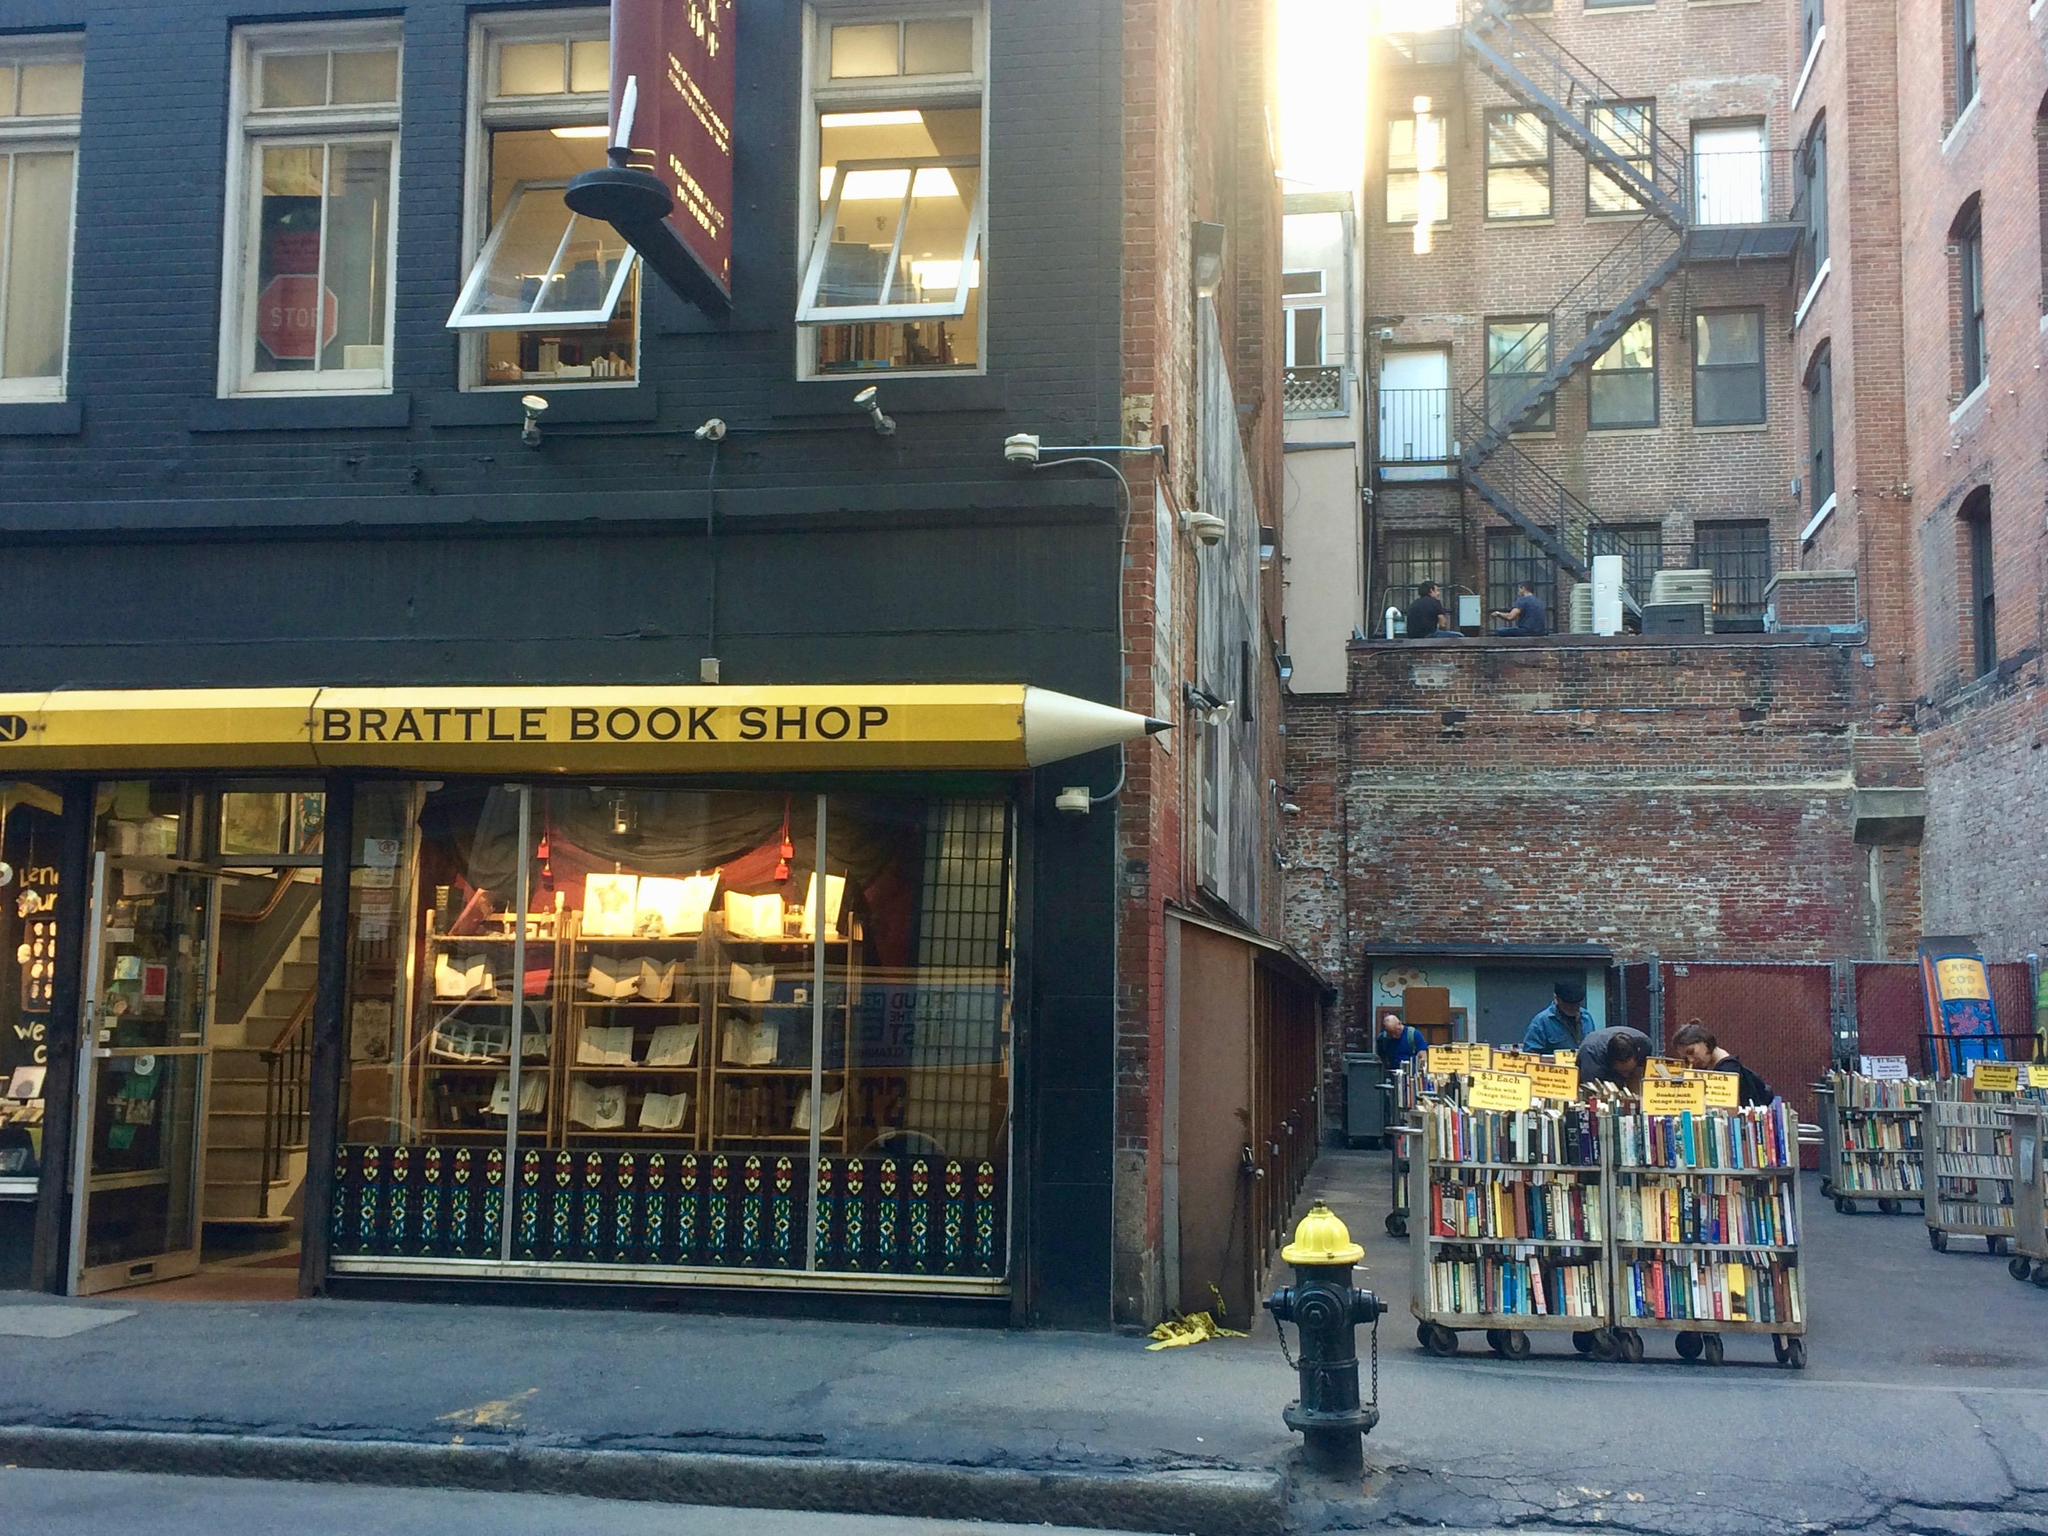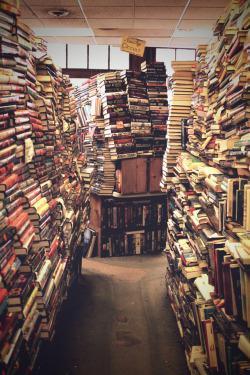The first image is the image on the left, the second image is the image on the right. Considering the images on both sides, is "Both are exterior views, but only the right image shows a yellow pencil shape pointing toward an area between brick buildings where wheeled carts of books are topped with yellow signs." valid? Answer yes or no. No. The first image is the image on the left, the second image is the image on the right. For the images displayed, is the sentence "People are looking at books in an alley in the image on the right." factually correct? Answer yes or no. No. 